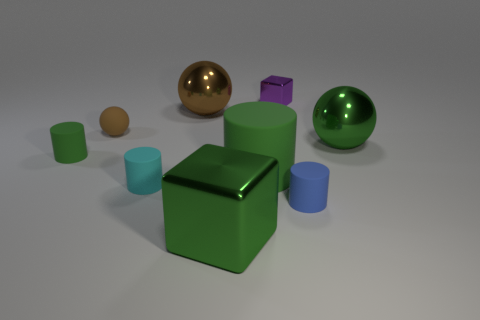Subtract all matte spheres. How many spheres are left? 2 Subtract all yellow cubes. How many green cylinders are left? 2 Subtract all purple blocks. How many blocks are left? 1 Subtract 1 cylinders. How many cylinders are left? 3 Subtract 0 brown cubes. How many objects are left? 9 Subtract all cylinders. How many objects are left? 5 Subtract all brown spheres. Subtract all gray blocks. How many spheres are left? 1 Subtract all tiny gray cylinders. Subtract all green metal things. How many objects are left? 7 Add 8 blue objects. How many blue objects are left? 9 Add 8 large red cylinders. How many large red cylinders exist? 8 